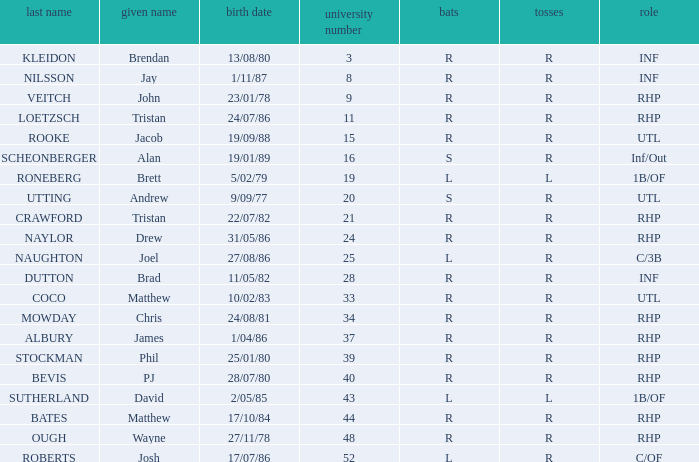Which Uni # has a Surname of ough? 48.0. 